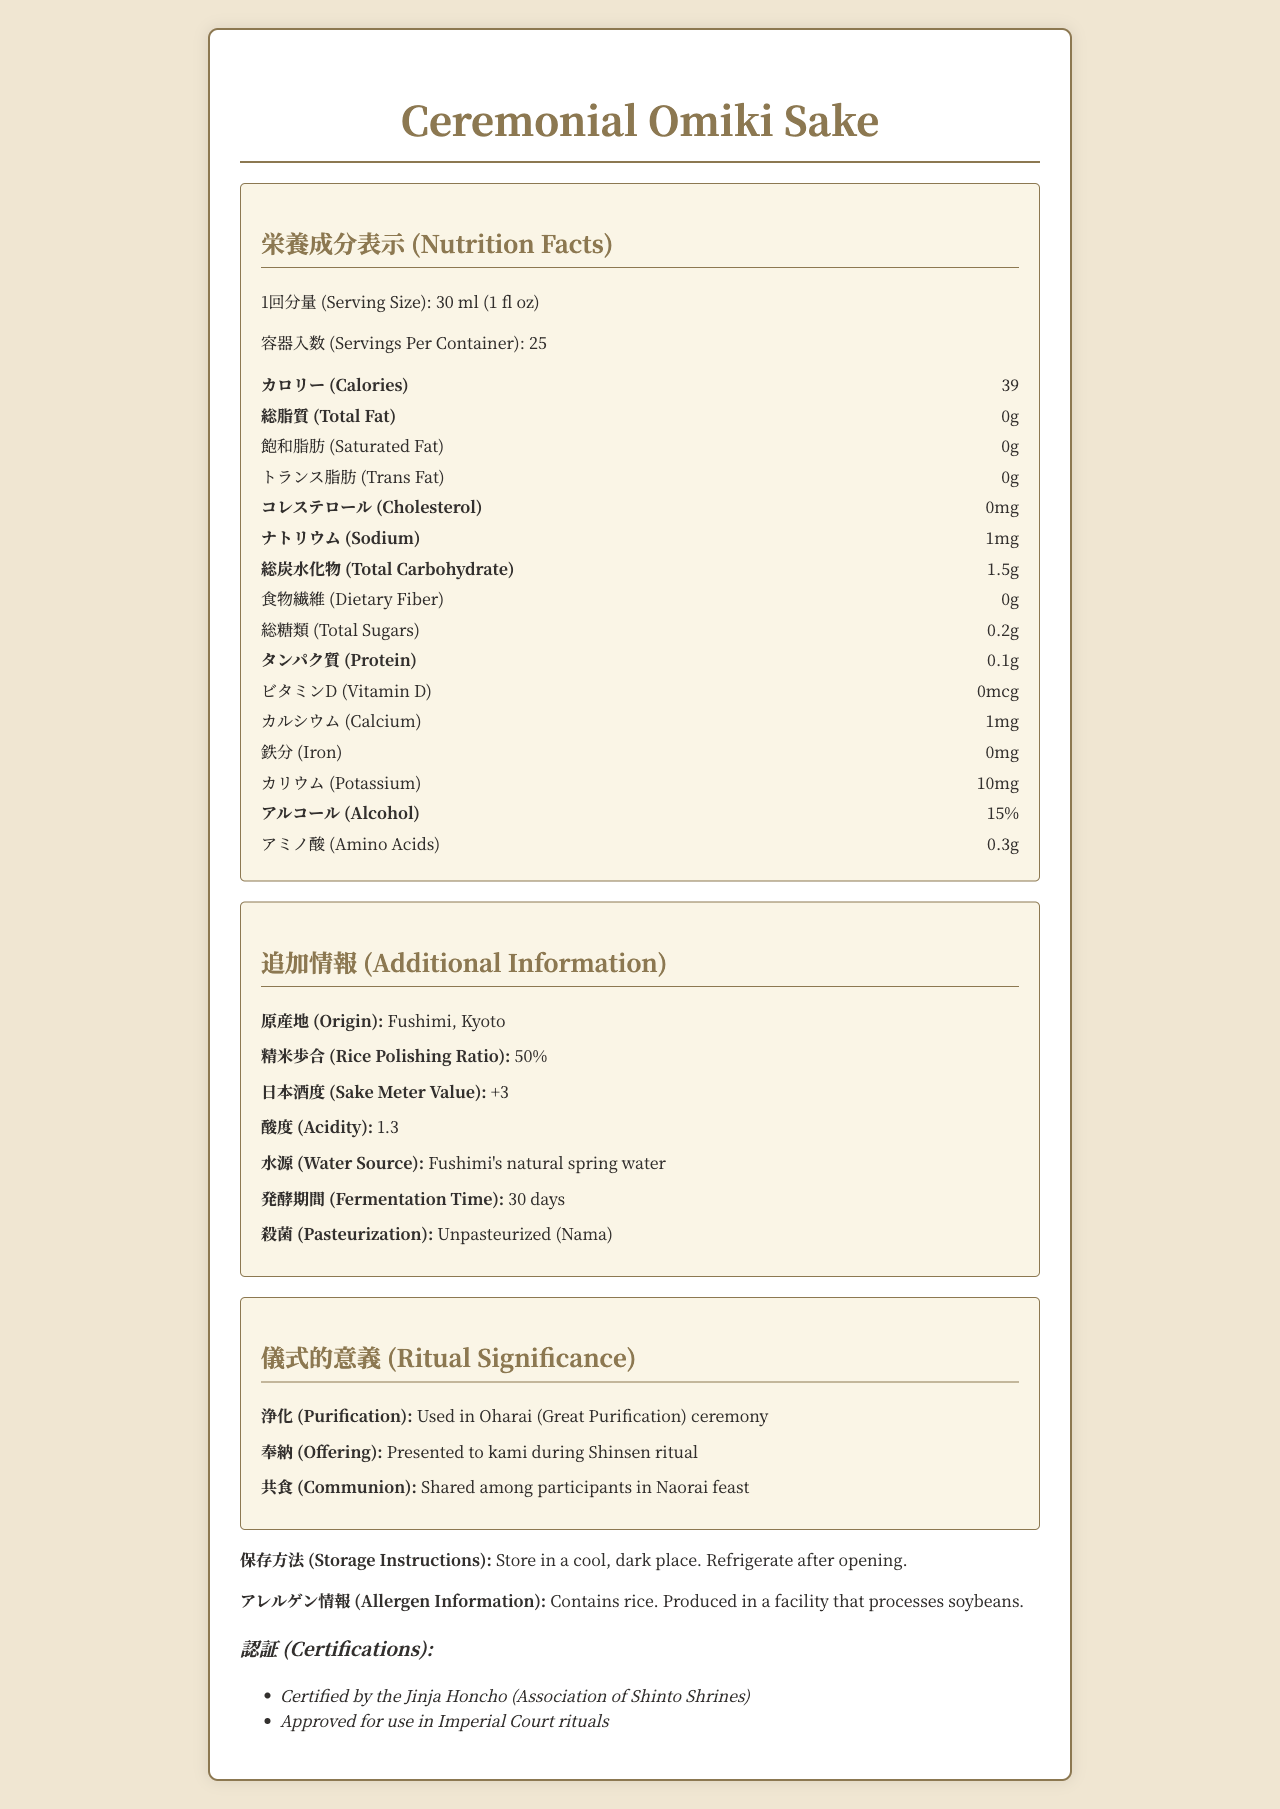what is the serving size of Ceremonial Omiki Sake? The label states that the serving size is 30 ml, which is equivalent to 1 fluid ounce.
Answer: 30 ml (1 fl oz) how many calories are in one serving of Ceremonial Omiki Sake? The document lists the calories per serving as 39.
Answer: 39 what is the amount of alcohol in Ceremonial Omiki Sake? The alcohol content is specified as 15% in the document.
Answer: 15% what is the rice polishing ratio for Ceremonial Omiki Sake? The additional information section states that the rice polishing ratio is 50%.
Answer: 50% where is Ceremonial Omiki Sake produced? The origin of the sake is Fushimi, Kyoto, as specified under additional information.
Answer: Fushimi, Kyoto what is the sodium content per serving? The nutritional facts indicate that the sodium content per serving is 1 mg.
Answer: 1 mg which ceremony uses Ceremonial Omiki Sake for purification? A. Naorai feast B. Oharai ceremony C. Shinsen ritual D. Jinja Honcho ritual The ritual significance section specifies that Ceremonial Omiki Sake is used in the Oharai (Great Purification) ceremony for purification.
Answer: B. Oharai ceremony what are the certifications of Ceremonial Omiki Sake? A. Certified Organic B. Jinja Honcho certified C. Imperial Court approval D. Both B and C The certifications include "Certified by the Jinja Honcho (Association of Shinto Shrines)" and "Approved for use in Imperial Court rituals."
Answer: D. Both B and C what ingredient might cause allergies? The allergen information states that the product contains rice and is produced in a facility that processes soybeans.
Answer: Rice is Ceremonial Omiki Sake pasteurized? The additional information mentions that the sake is unpasteurized (Nama).
Answer: No how many servings are there in one container of Ceremonial Omiki Sake? The document states that there are 25 servings per container.
Answer: 25 what type of water is used for brewing Ceremonial Omiki Sake? The additional information specifies that Fushimi's natural spring water is used as the water source.
Answer: Fushimi's natural spring water list all the nutritional contents that have a value of zero in Ceremonial Omiki Sake. The nutritional facts show that the values for Total Fat, Saturated Fat, Trans Fat, Cholesterol, Dietary Fiber, Vitamin D, and Iron are all zero.
Answer: Total Fat, Saturated Fat, Trans Fat, Cholesterol, Dietary Fiber, Vitamin D, Iron how should Ceremonial Omiki Sake be stored after opening? The storage instructions advise refrigeration after opening.
Answer: Refrigerate what is the primary function of Ceremonial Omiki Sake in Shinto rituals? The document states that it is used for offering to kami during the Shinsen ritual.
Answer: Offering to kami during Shinsen ritual describe the main aspects of the document The document is a comprehensive presentation of the nutritional facts, additional details, ritual significance, and storage instructions for Ceremonial Omiki Sake, emphasizing its use in Shinto rites.
Answer: The document provides nutritional and additional information about Ceremonial Omiki Sake, including its origin, ingredients, and use in Shinto rituals. It specifies the serving size, nutritional content, ingredients, allergens, storage instructions, and certifications. It also details the significance of the sake in various Shinto ceremonies. what is the exact fermentation time for Ceremonial Omiki Sake? The additional information section lists the fermentation time as 30 days.
Answer: 30 days what is the exact amount of protein in Ceremonial Omiki Sake? A. 0.5g B. 0.2g C. 0.1g D. 1g The nutritional facts indicate that the protein content per serving is 0.1g.
Answer: C. 0.1g what is the sake meter value and what does it represent? The document states a sake meter value of +3, representing the scale of the sake’s sweetness and dryness (higher values usually indicate dryness).
Answer: +3 when should Ceremonial Omiki Sake be consumed during Shinto rituals? The ritual significance section mentions that it is shared among participants in the Naorai feast.
Answer: During the Naorai feast who grows the rice used in Ceremonial Omiki Sake? The document provides information on the rice polishing ratio and allergen details but does not mention who grows the rice.
Answer: Cannot be determined 